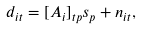<formula> <loc_0><loc_0><loc_500><loc_500>d _ { i t } = [ A _ { i } ] _ { t p } s _ { p } + n _ { i t } ,</formula> 